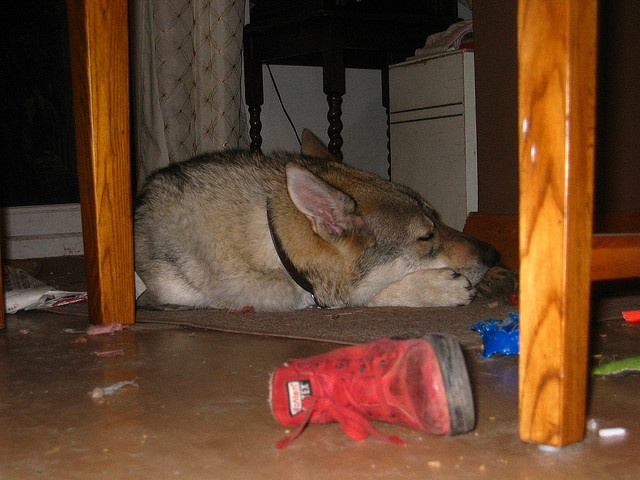Describe the objects in this image and their specific colors. I can see chair in black, brown, orange, and maroon tones, dog in black, gray, and maroon tones, and chair in black and gray tones in this image. 